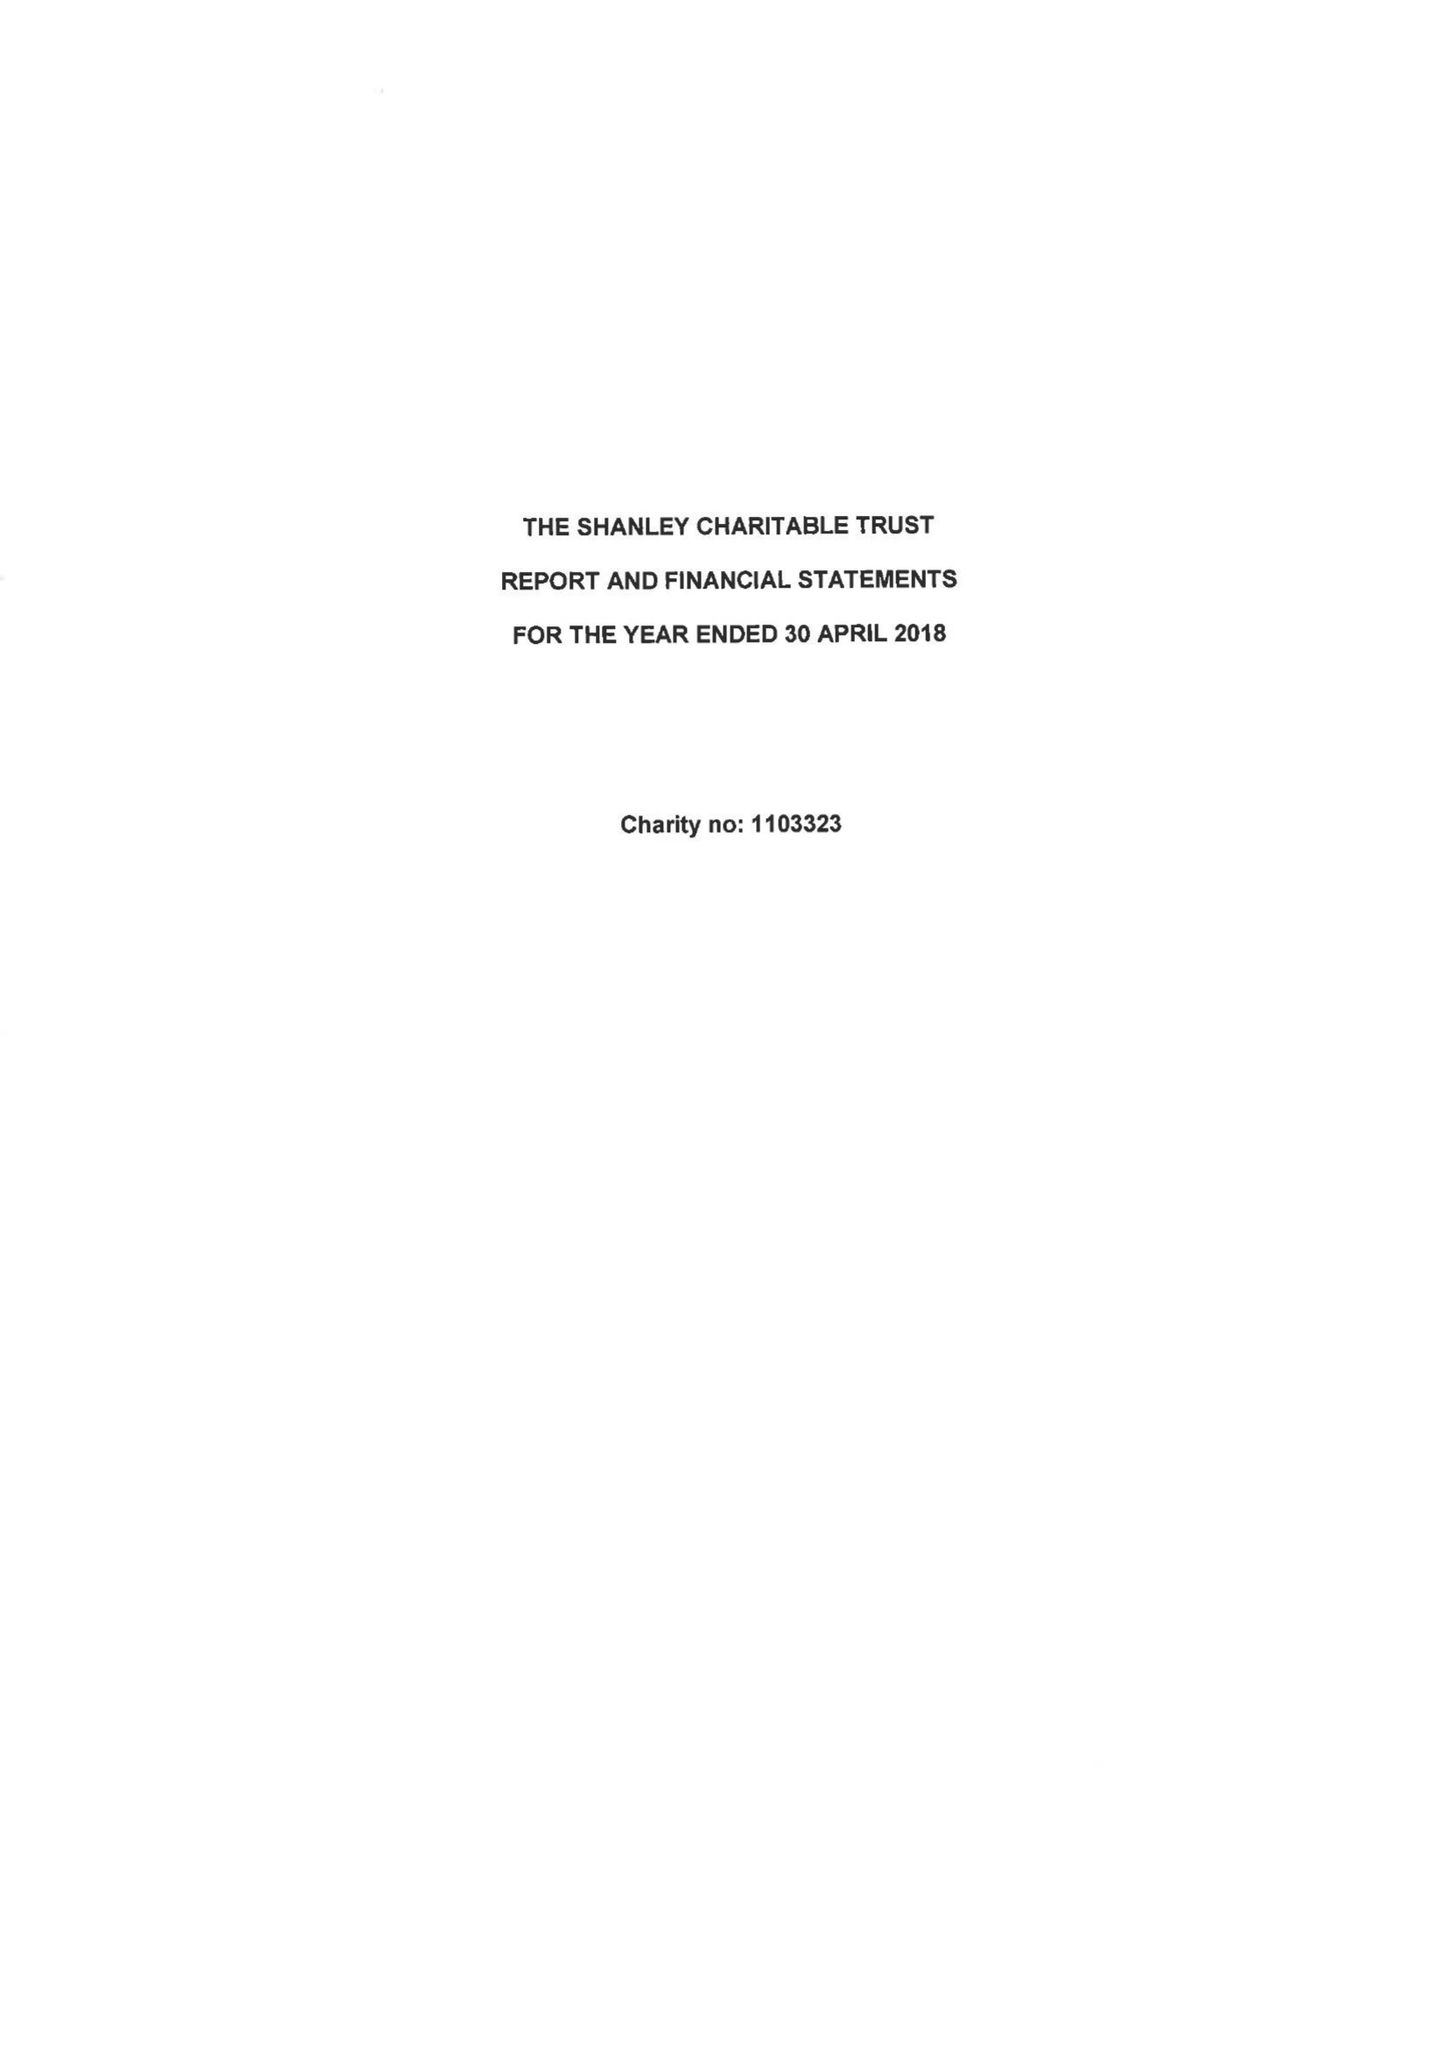What is the value for the address__street_line?
Answer the question using a single word or phrase. 13 WESTBURY ROAD 